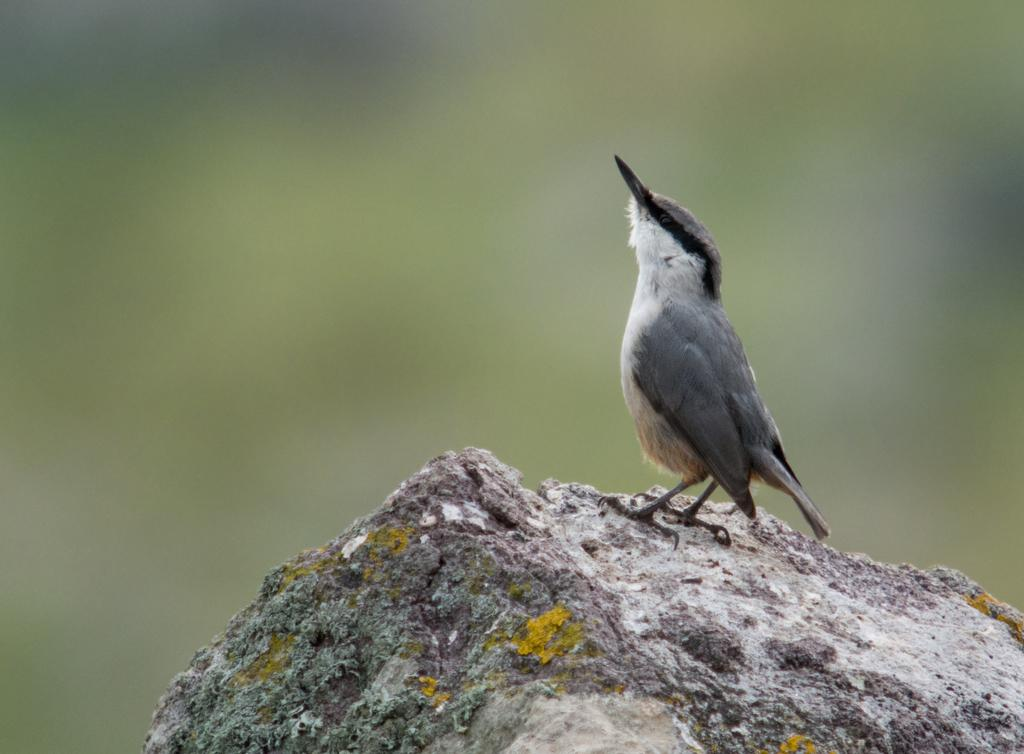What type of animal is in the image? There is a bird in the image. What is the bird standing on? The bird is standing on a stone. Can you describe the background of the image? The background of the image is blurred. What type of ship can be seen in the image? There is no ship present in the image; it features a bird standing on a stone with a blurred background. 